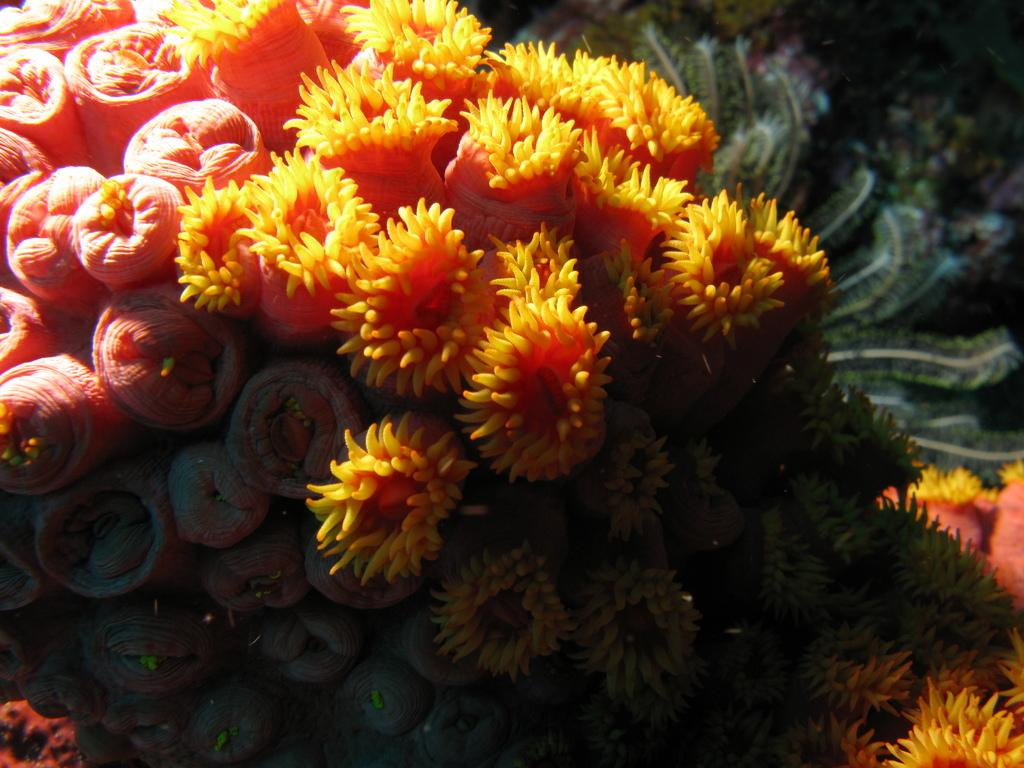What type of natural formation can be seen in the image? There are coral reefs in the image. Can you describe the appearance of the coral reefs? The coral reefs have a colorful and intricate structure. What might be living in or around the coral reefs? Various marine life, such as fish and sea turtles, might be living in or around the coral reefs. How does the father participate in the rainstorm depicted in the image? There is no rainstorm or father present in the image; it features coral reefs. 